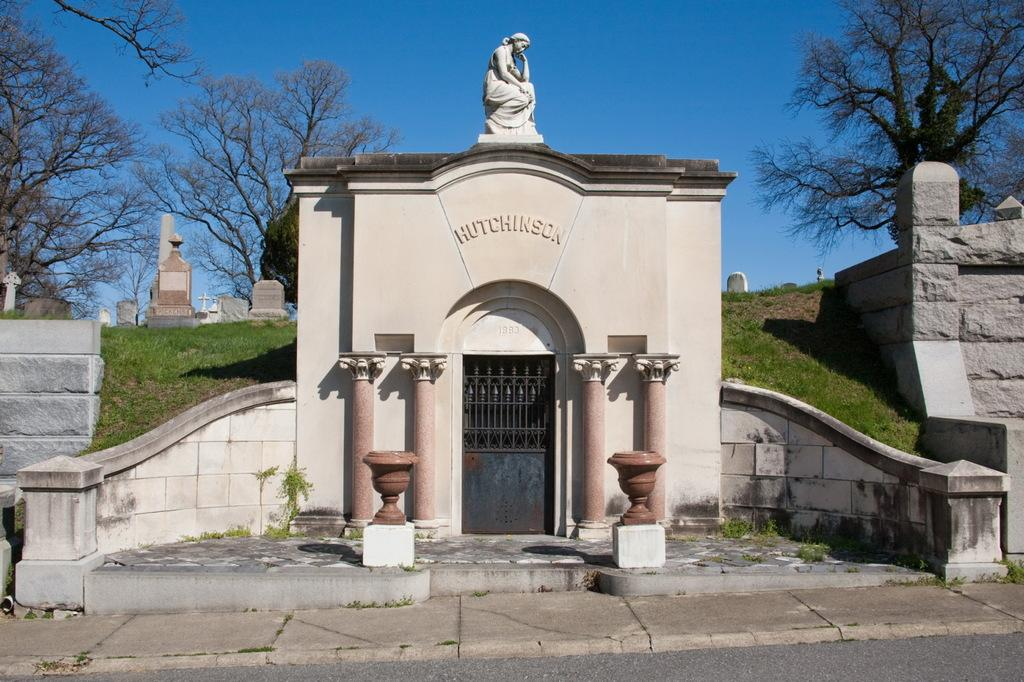What type of path is visible in the image? There is a footpath in the image. What structures can be seen in the image? There are walls, a door, and a statue in the image. What type of plants are present in the image? There is grass, trees, and pots with plants in the image. What type of area might this image represent? The image might represent a cemetery, given the presence of graves. What is visible in the background of the image? The sky is visible in the background of the image. What type of stitch is used to create the pattern on the farm in the image? There is no farm present in the image, and therefore no pattern to discuss. How many rings are visible on the fingers of the people in the image? There are no people visible in the image, so it is impossible to determine the number of rings on their fingers. 